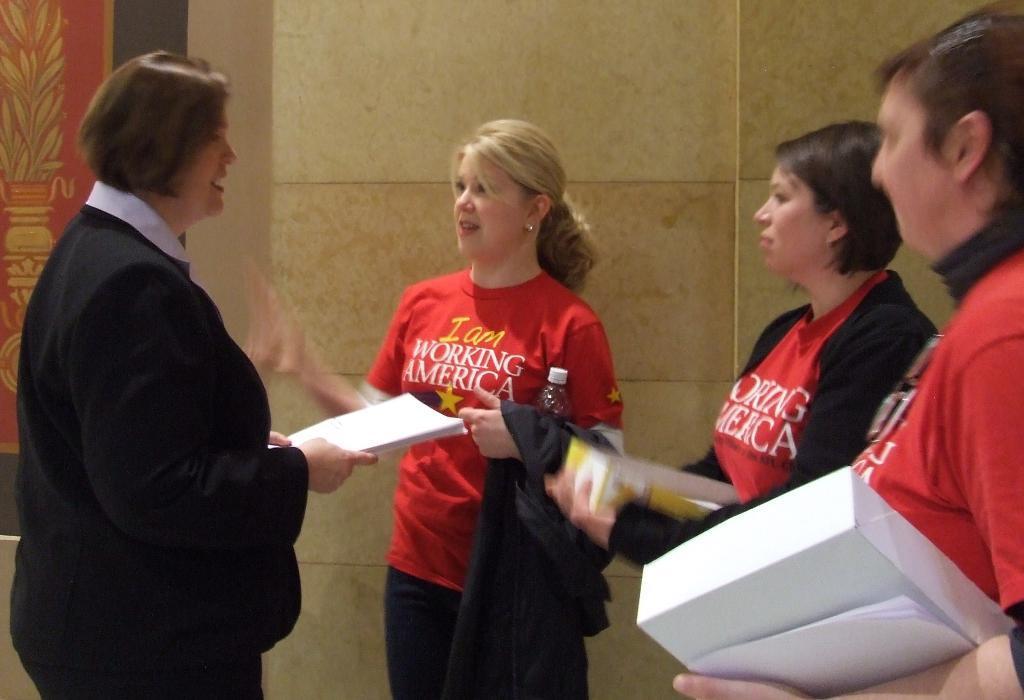Can you describe this image briefly? In the image on the left side there is a lady standing and holding papers in her hands. In front of her there are three ladies standing and holding few objects in their hands. Behind them there is a wall with a frame. 